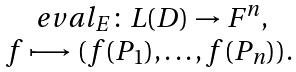<formula> <loc_0><loc_0><loc_500><loc_500>\begin{array} { c } \ e v a l _ { E } \colon L ( D ) \rightarrow F ^ { n } , \\ f \longmapsto ( f ( P _ { 1 } ) , \dots , f ( P _ { n } ) ) . \end{array}</formula> 